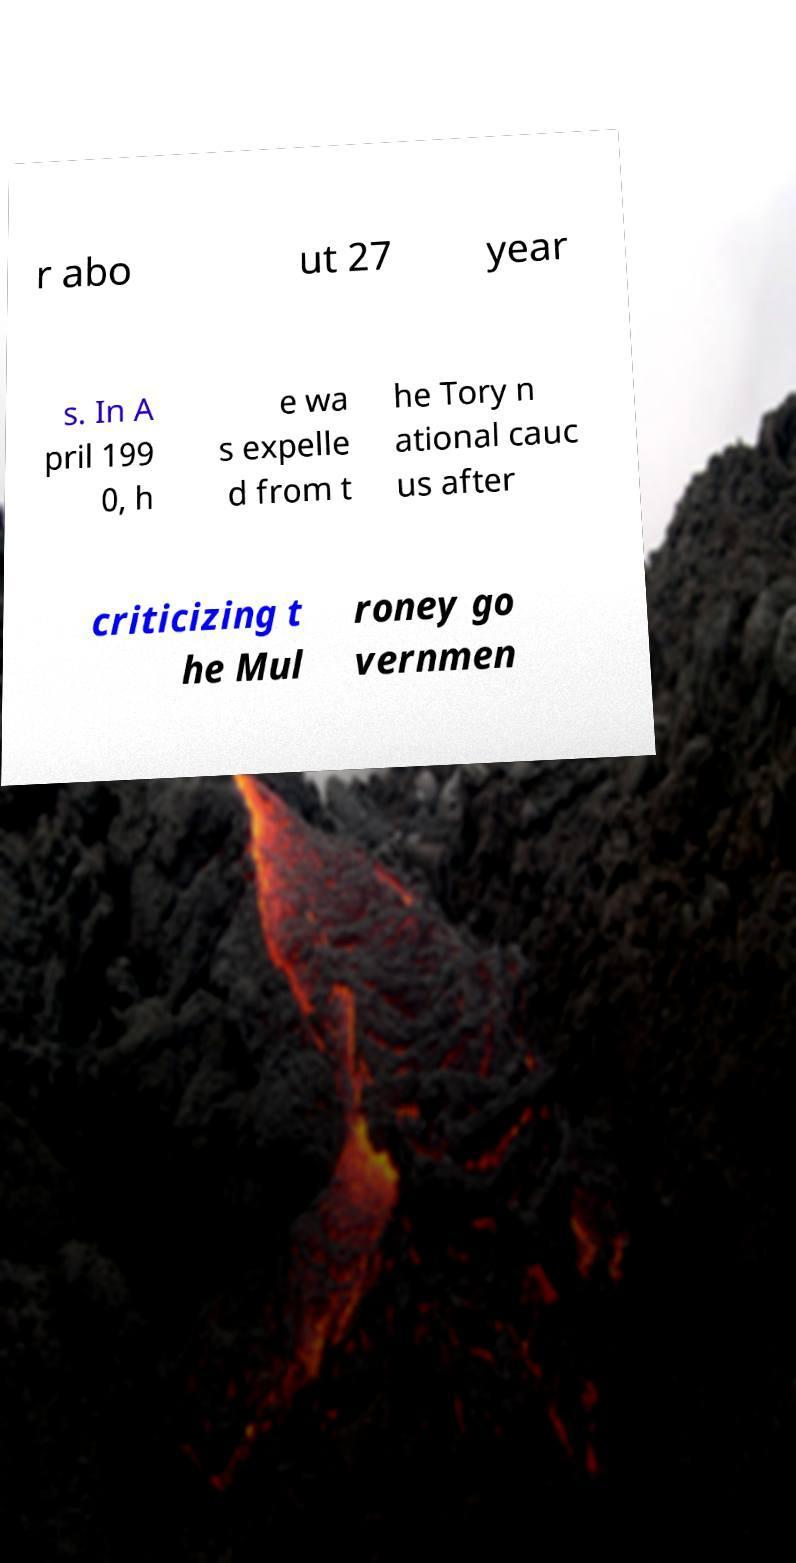For documentation purposes, I need the text within this image transcribed. Could you provide that? r abo ut 27 year s. In A pril 199 0, h e wa s expelle d from t he Tory n ational cauc us after criticizing t he Mul roney go vernmen 